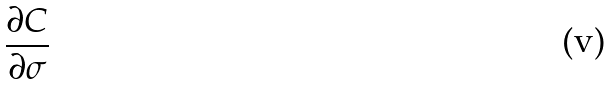Convert formula to latex. <formula><loc_0><loc_0><loc_500><loc_500>\frac { \partial C } { \partial \sigma }</formula> 